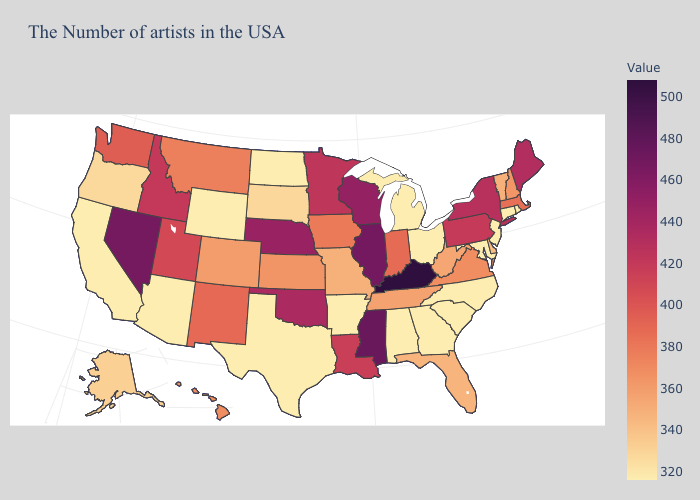Does Maryland have the lowest value in the South?
Short answer required. Yes. Is the legend a continuous bar?
Be succinct. Yes. Which states have the lowest value in the USA?
Short answer required. Rhode Island, Connecticut, New Jersey, Maryland, North Carolina, South Carolina, Ohio, Georgia, Michigan, Alabama, Arkansas, Texas, North Dakota, Wyoming, Arizona, California. Among the states that border Tennessee , which have the highest value?
Answer briefly. Kentucky. Does Illinois have the highest value in the MidWest?
Give a very brief answer. Yes. 